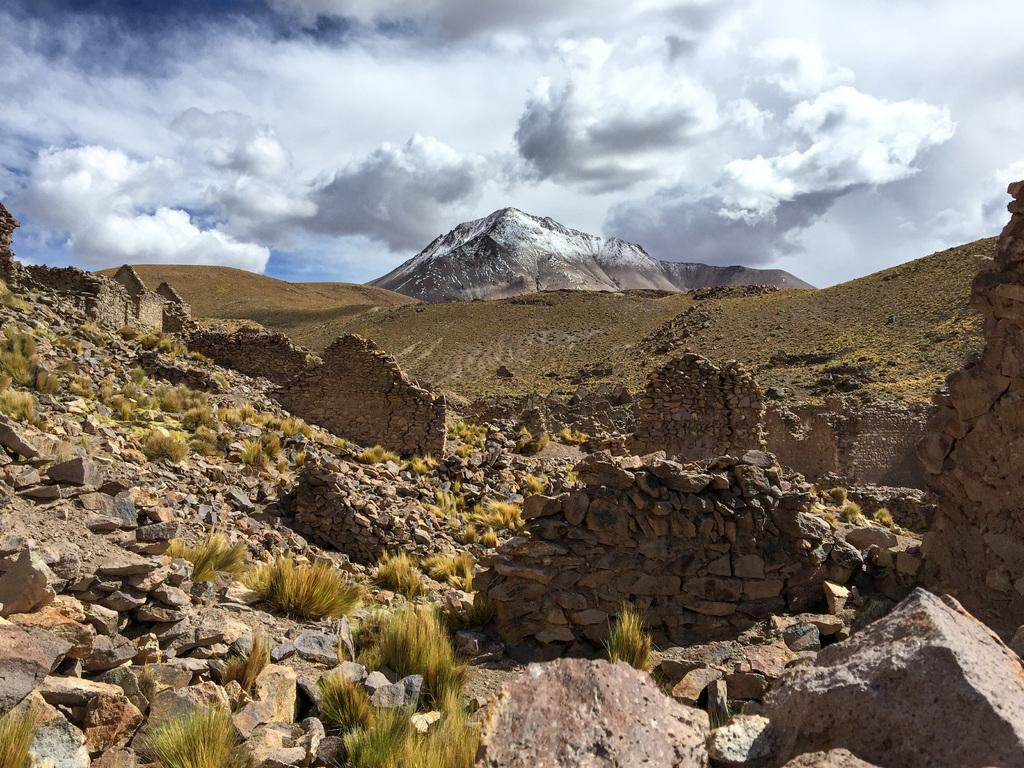What type of natural elements can be seen in the image? There are rocks and grass visible in the image. Where are the rocks and grass located? The grass and rocks are on the land in the image. What can be seen in the middle of the image? There are hills in the middle of the image. What is visible at the top of the image? The sky is visible at the top of the image. What can be observed in the sky? There are clouds in the sky. What attempt can be seen in the image? There is no attempt visible in the image. 